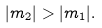<formula> <loc_0><loc_0><loc_500><loc_500>| m _ { 2 } | > | m _ { 1 } | .</formula> 